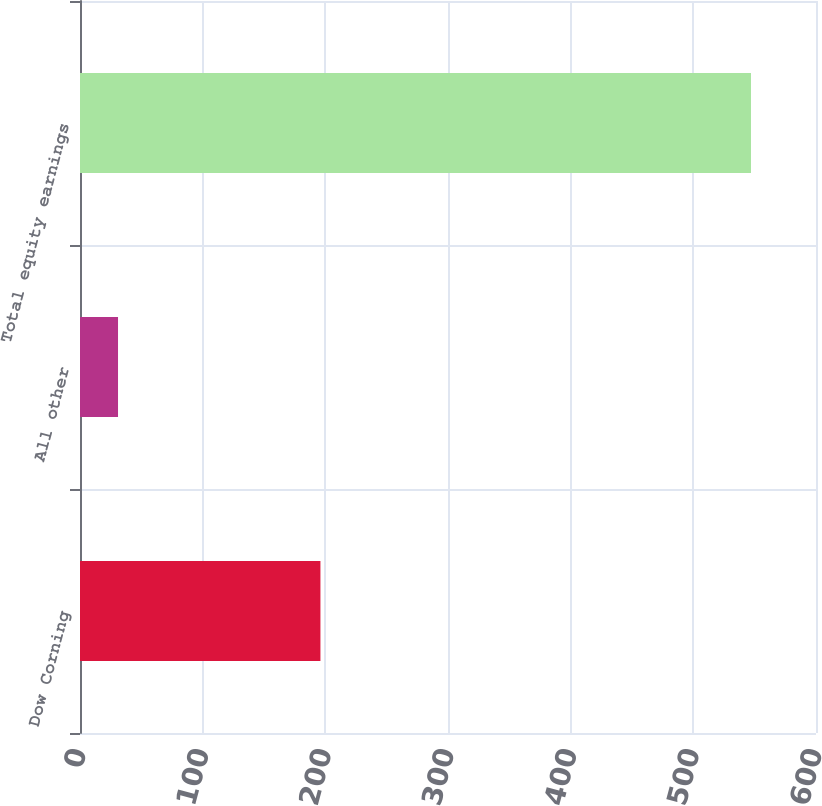Convert chart to OTSL. <chart><loc_0><loc_0><loc_500><loc_500><bar_chart><fcel>Dow Corning<fcel>All other<fcel>Total equity earnings<nl><fcel>196<fcel>31<fcel>547<nl></chart> 